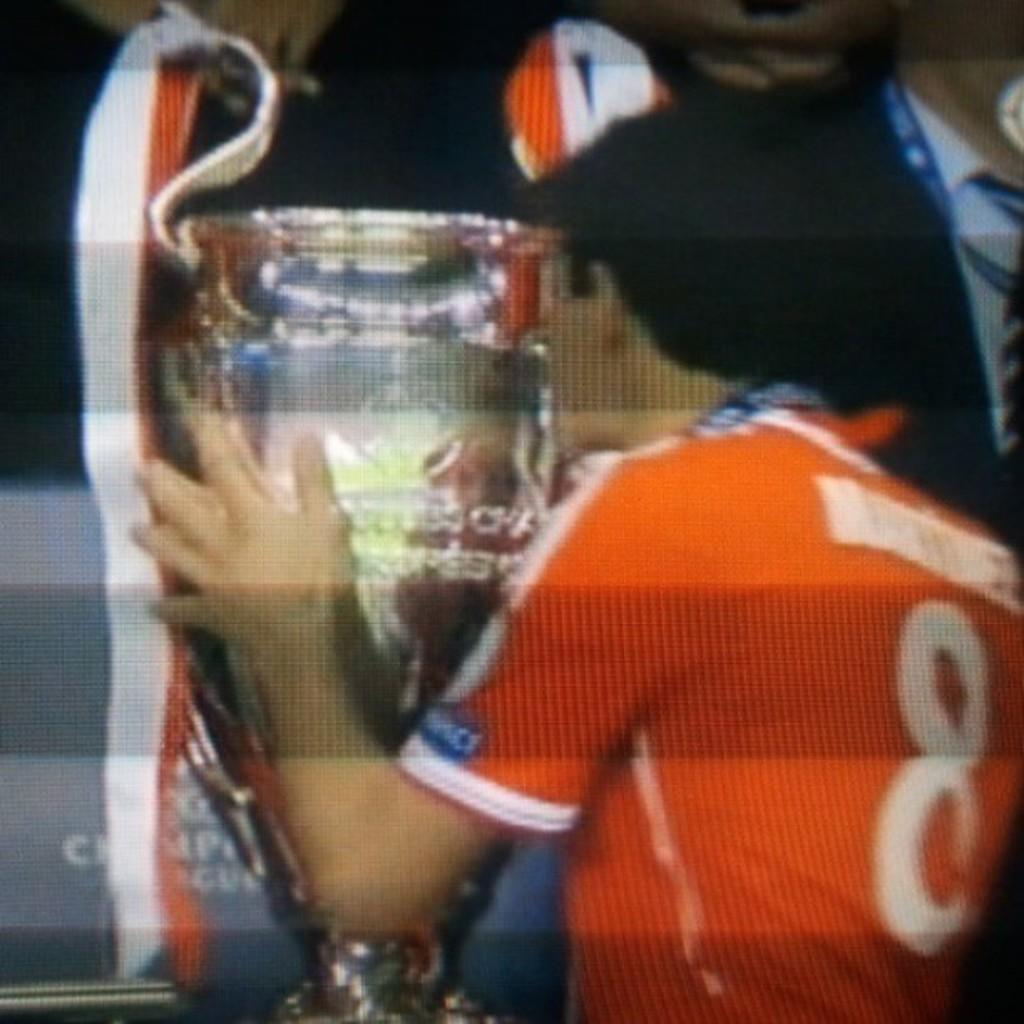<image>
Summarize the visual content of the image. a man in a number eight jersey kissing a trophy 